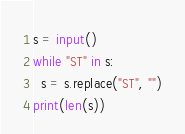Convert code to text. <code><loc_0><loc_0><loc_500><loc_500><_Python_>s = input()
while "ST" in s:
  s = s.replace("ST", "")
print(len(s))</code> 